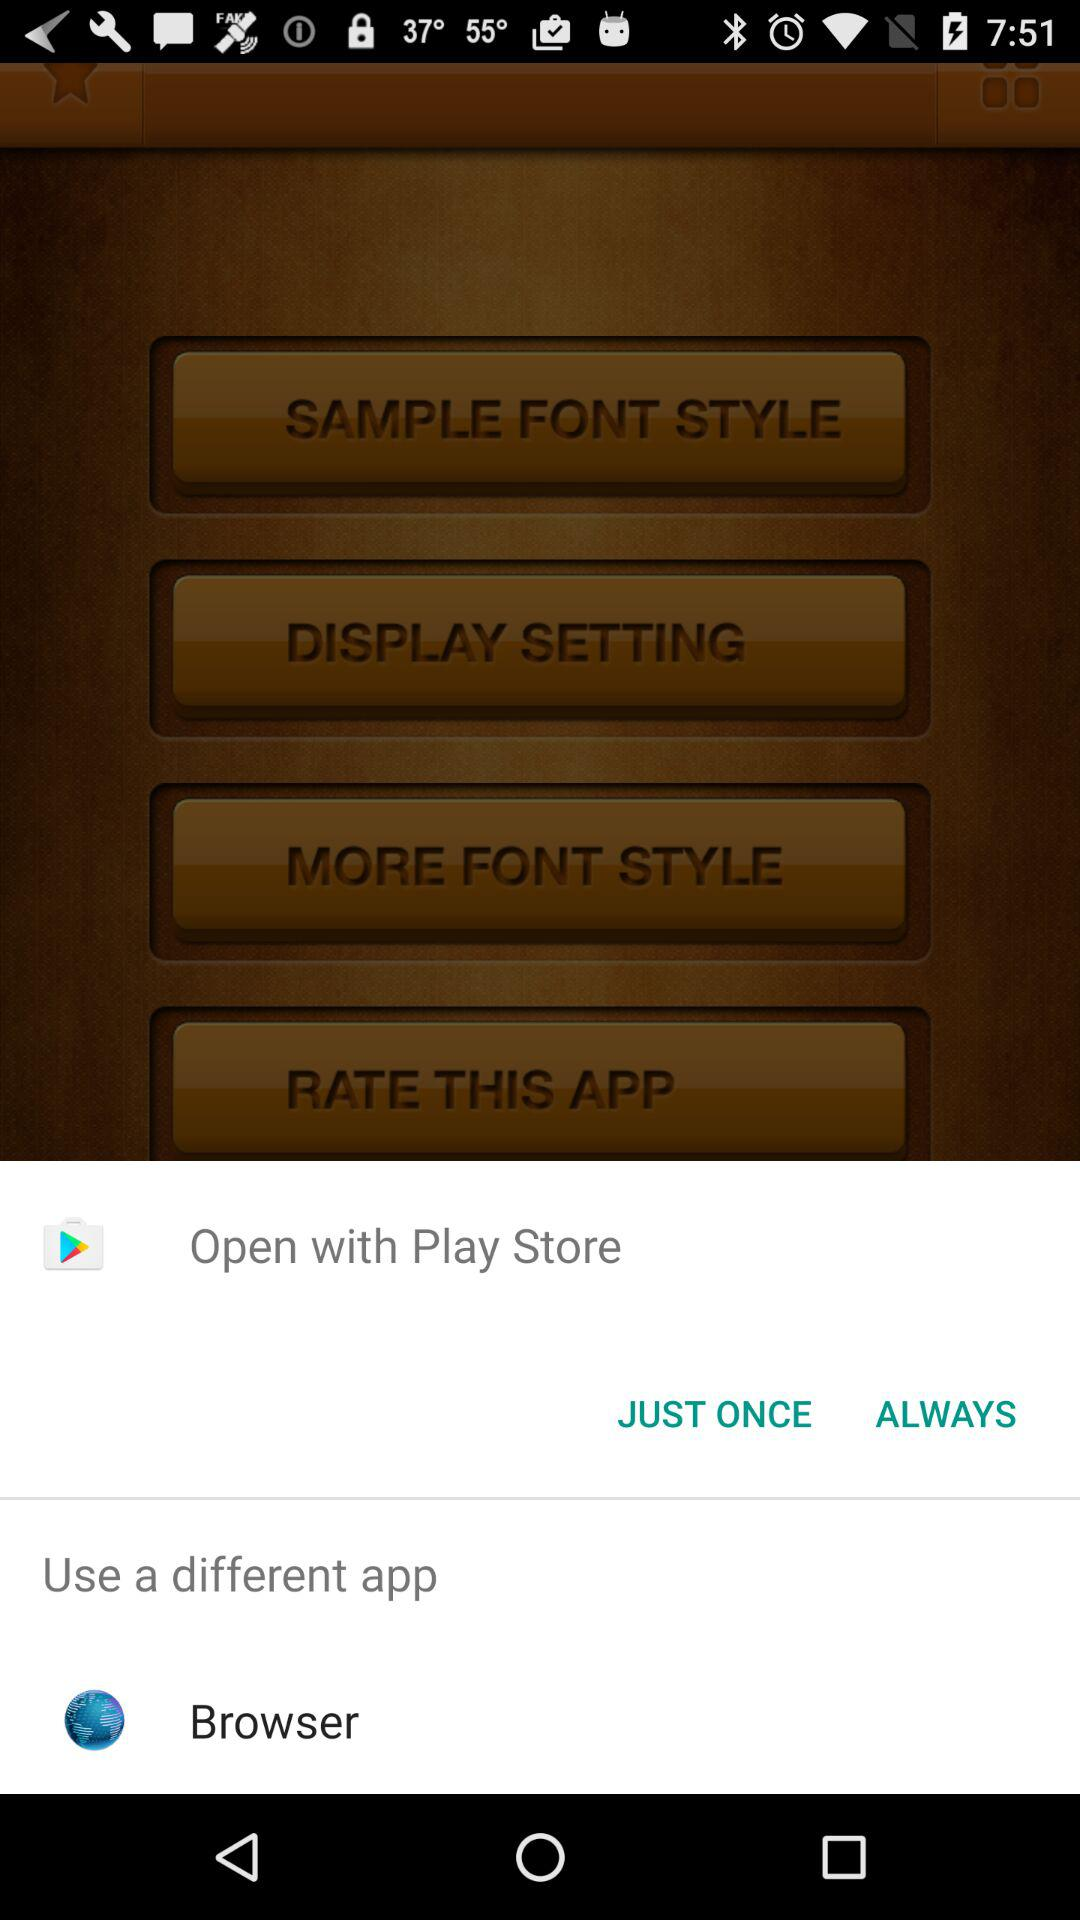Through what applications can users open them? The applications are "Play Store" and "Browser". 